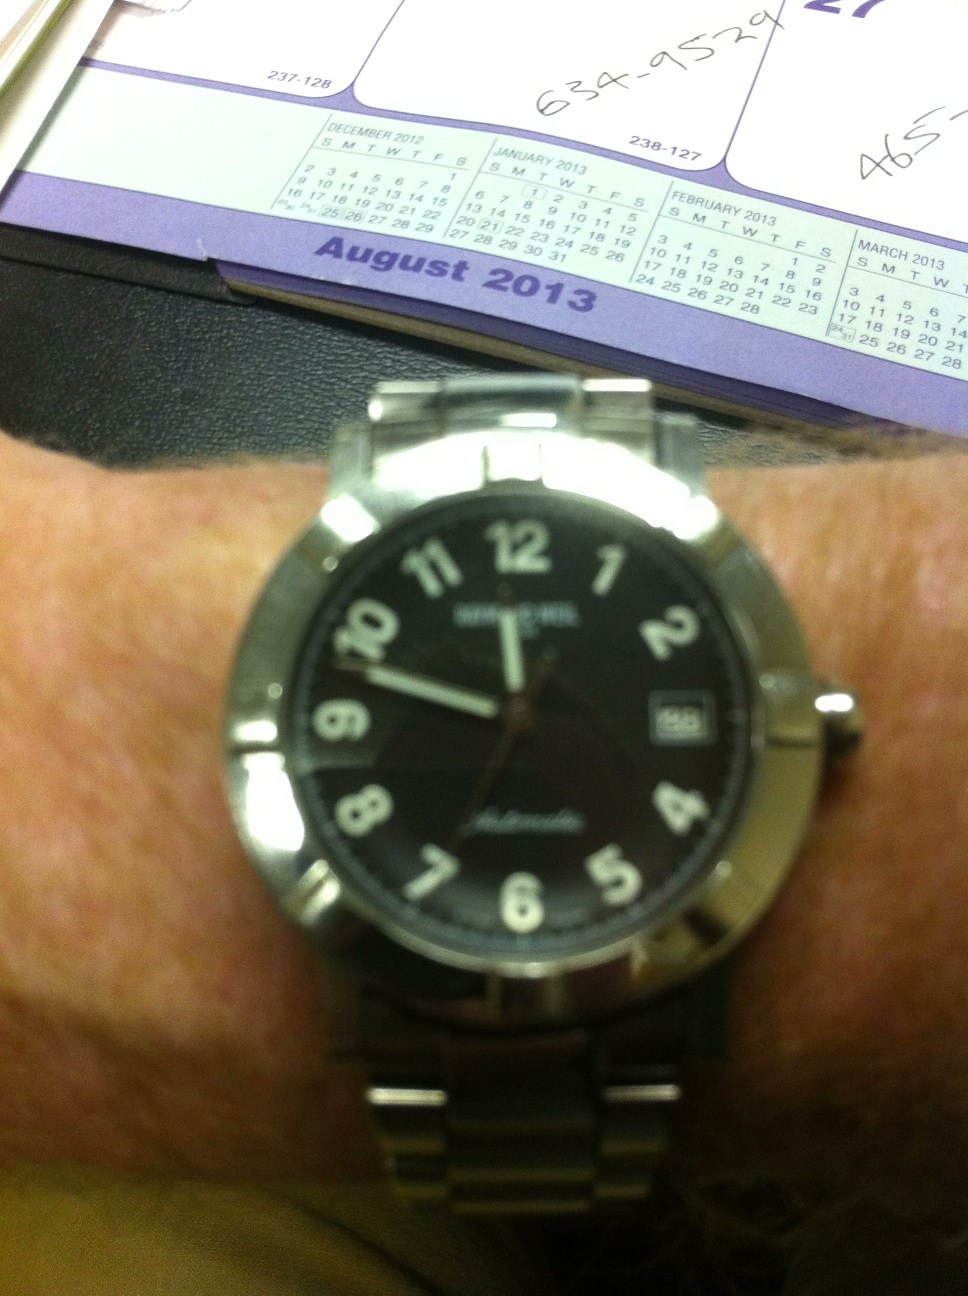What could the numbers scribbled on the calendar in the background tell us? The numbers written on the calendar could be indications of important appointments or reminders for specific days. They appear to be hastily scribbled, possibly highlighting urgent or last-minute notes. This detail can suggest a busy schedule for the person owning this workspace. 